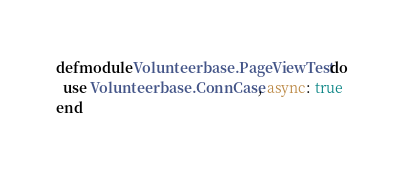<code> <loc_0><loc_0><loc_500><loc_500><_Elixir_>defmodule Volunteerbase.PageViewTest do
  use Volunteerbase.ConnCase, async: true
end
</code> 